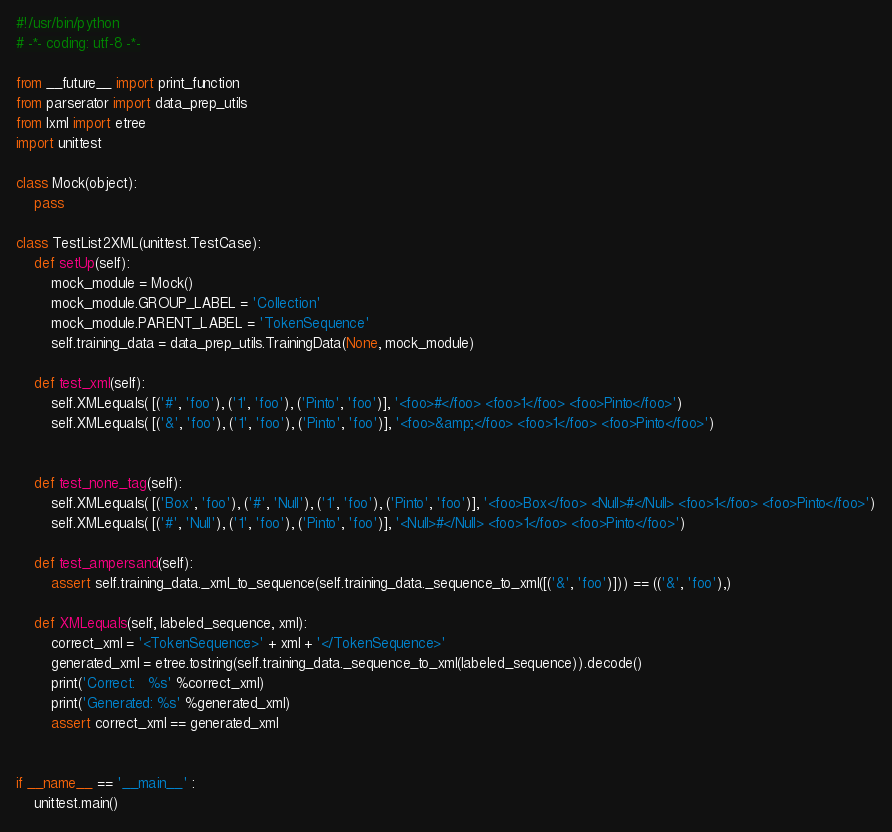Convert code to text. <code><loc_0><loc_0><loc_500><loc_500><_Python_>#!/usr/bin/python
# -*- coding: utf-8 -*-

from __future__ import print_function
from parserator import data_prep_utils
from lxml import etree
import unittest

class Mock(object):
    pass

class TestList2XML(unittest.TestCase):
    def setUp(self):
        mock_module = Mock()
        mock_module.GROUP_LABEL = 'Collection'
        mock_module.PARENT_LABEL = 'TokenSequence'
        self.training_data = data_prep_utils.TrainingData(None, mock_module)

    def test_xml(self):
        self.XMLequals( [('#', 'foo'), ('1', 'foo'), ('Pinto', 'foo')], '<foo>#</foo> <foo>1</foo> <foo>Pinto</foo>')
        self.XMLequals( [('&', 'foo'), ('1', 'foo'), ('Pinto', 'foo')], '<foo>&amp;</foo> <foo>1</foo> <foo>Pinto</foo>')


    def test_none_tag(self):
        self.XMLequals( [('Box', 'foo'), ('#', 'Null'), ('1', 'foo'), ('Pinto', 'foo')], '<foo>Box</foo> <Null>#</Null> <foo>1</foo> <foo>Pinto</foo>')
        self.XMLequals( [('#', 'Null'), ('1', 'foo'), ('Pinto', 'foo')], '<Null>#</Null> <foo>1</foo> <foo>Pinto</foo>')

    def test_ampersand(self):
        assert self.training_data._xml_to_sequence(self.training_data._sequence_to_xml([('&', 'foo')])) == (('&', 'foo'),)
       
    def XMLequals(self, labeled_sequence, xml):
        correct_xml = '<TokenSequence>' + xml + '</TokenSequence>'
        generated_xml = etree.tostring(self.training_data._sequence_to_xml(labeled_sequence)).decode()
        print('Correct:   %s' %correct_xml)
        print('Generated: %s' %generated_xml)
        assert correct_xml == generated_xml


if __name__ == '__main__' :
    unittest.main()    
</code> 